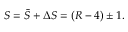Convert formula to latex. <formula><loc_0><loc_0><loc_500><loc_500>S = \bar { S } + \Delta S = ( R - 4 ) \pm 1 .</formula> 